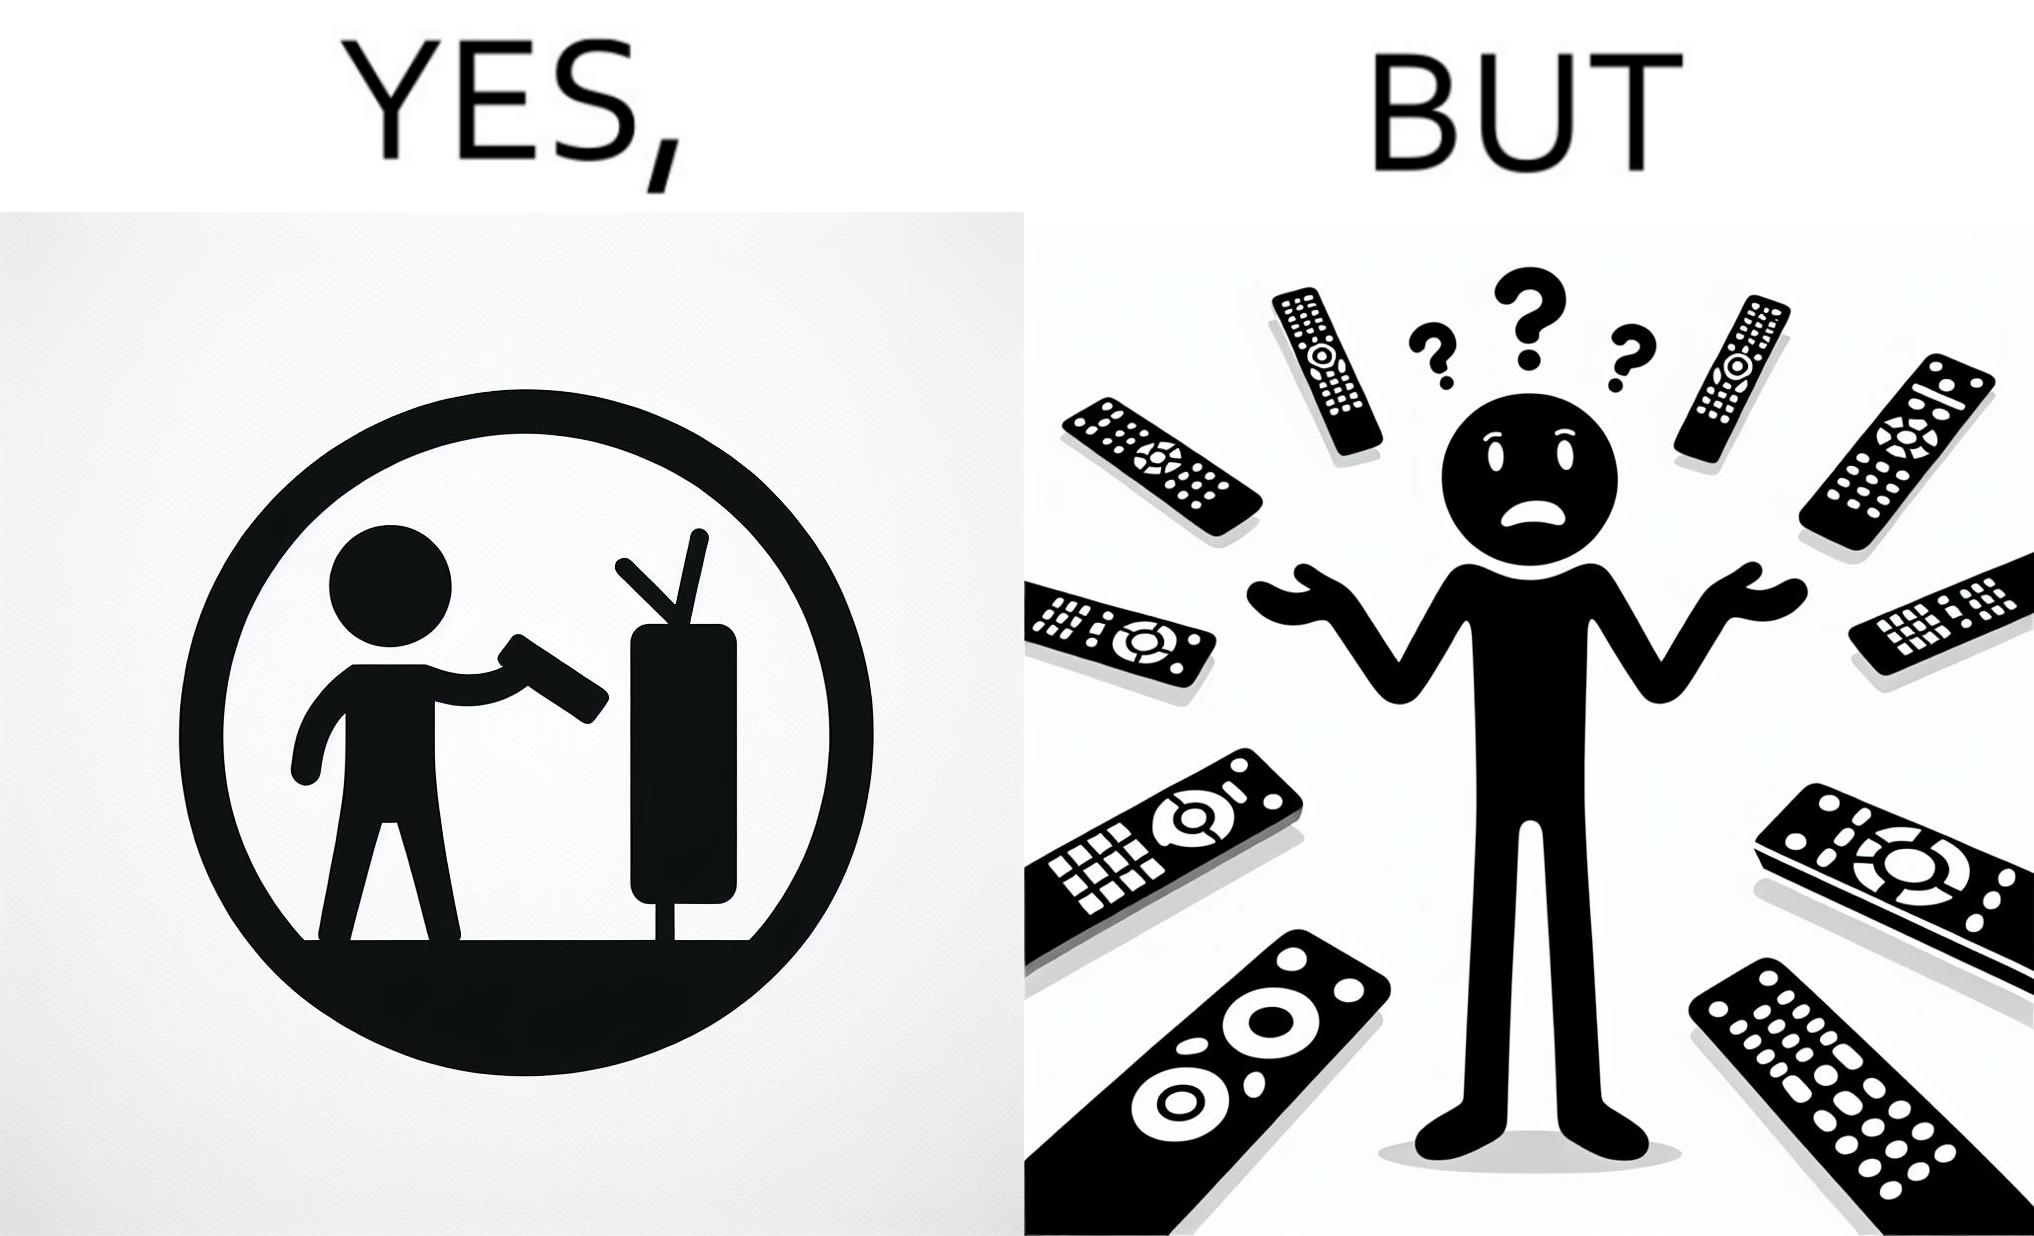Describe what you see in this image. The images are funny since they show how even though TV remotes are supposed to make operating TVs easier, having multiple similar looking remotes  for everything only makes it more difficult for the user to use the right one 